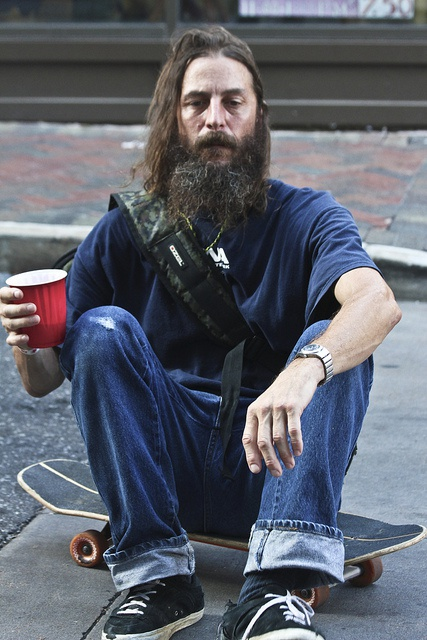Describe the objects in this image and their specific colors. I can see people in black, navy, gray, and lightgray tones, skateboard in black, gray, and darkgray tones, backpack in black, gray, and purple tones, cup in black, maroon, white, and brown tones, and clock in black, lightgray, darkgray, and lightblue tones in this image. 